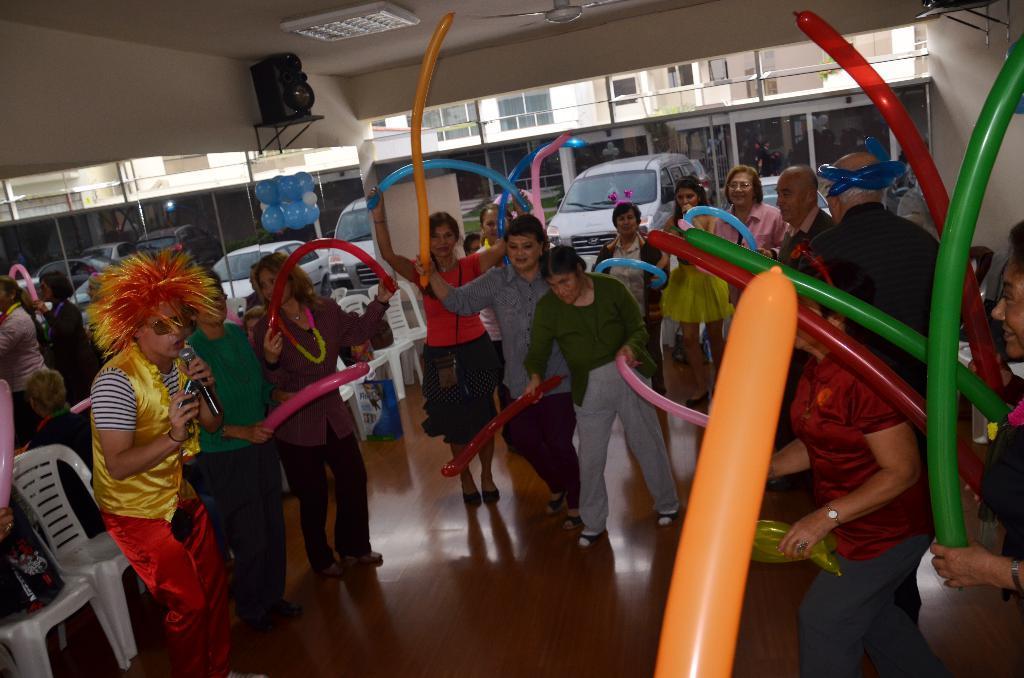Please provide a concise description of this image. This picture describes about group of people, few people are holding balloons, in the left side of the given image we can see a person, he is singing with the help of microphone, beside to him we can see chairs, in the background we can find a speaker, buildings and vehicles. 